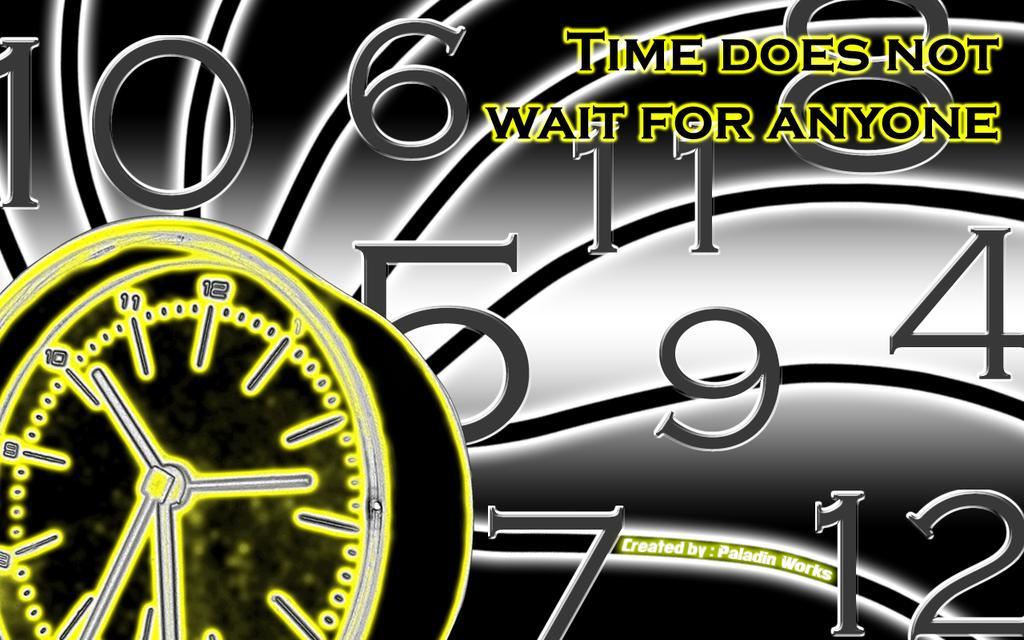Could you give a brief overview of what you see in this image? In the picture we can see a poster with an animated picture of a watch and behind it, we can see numbers and a name on the top of it as "Time doesn't wait for anyone". 